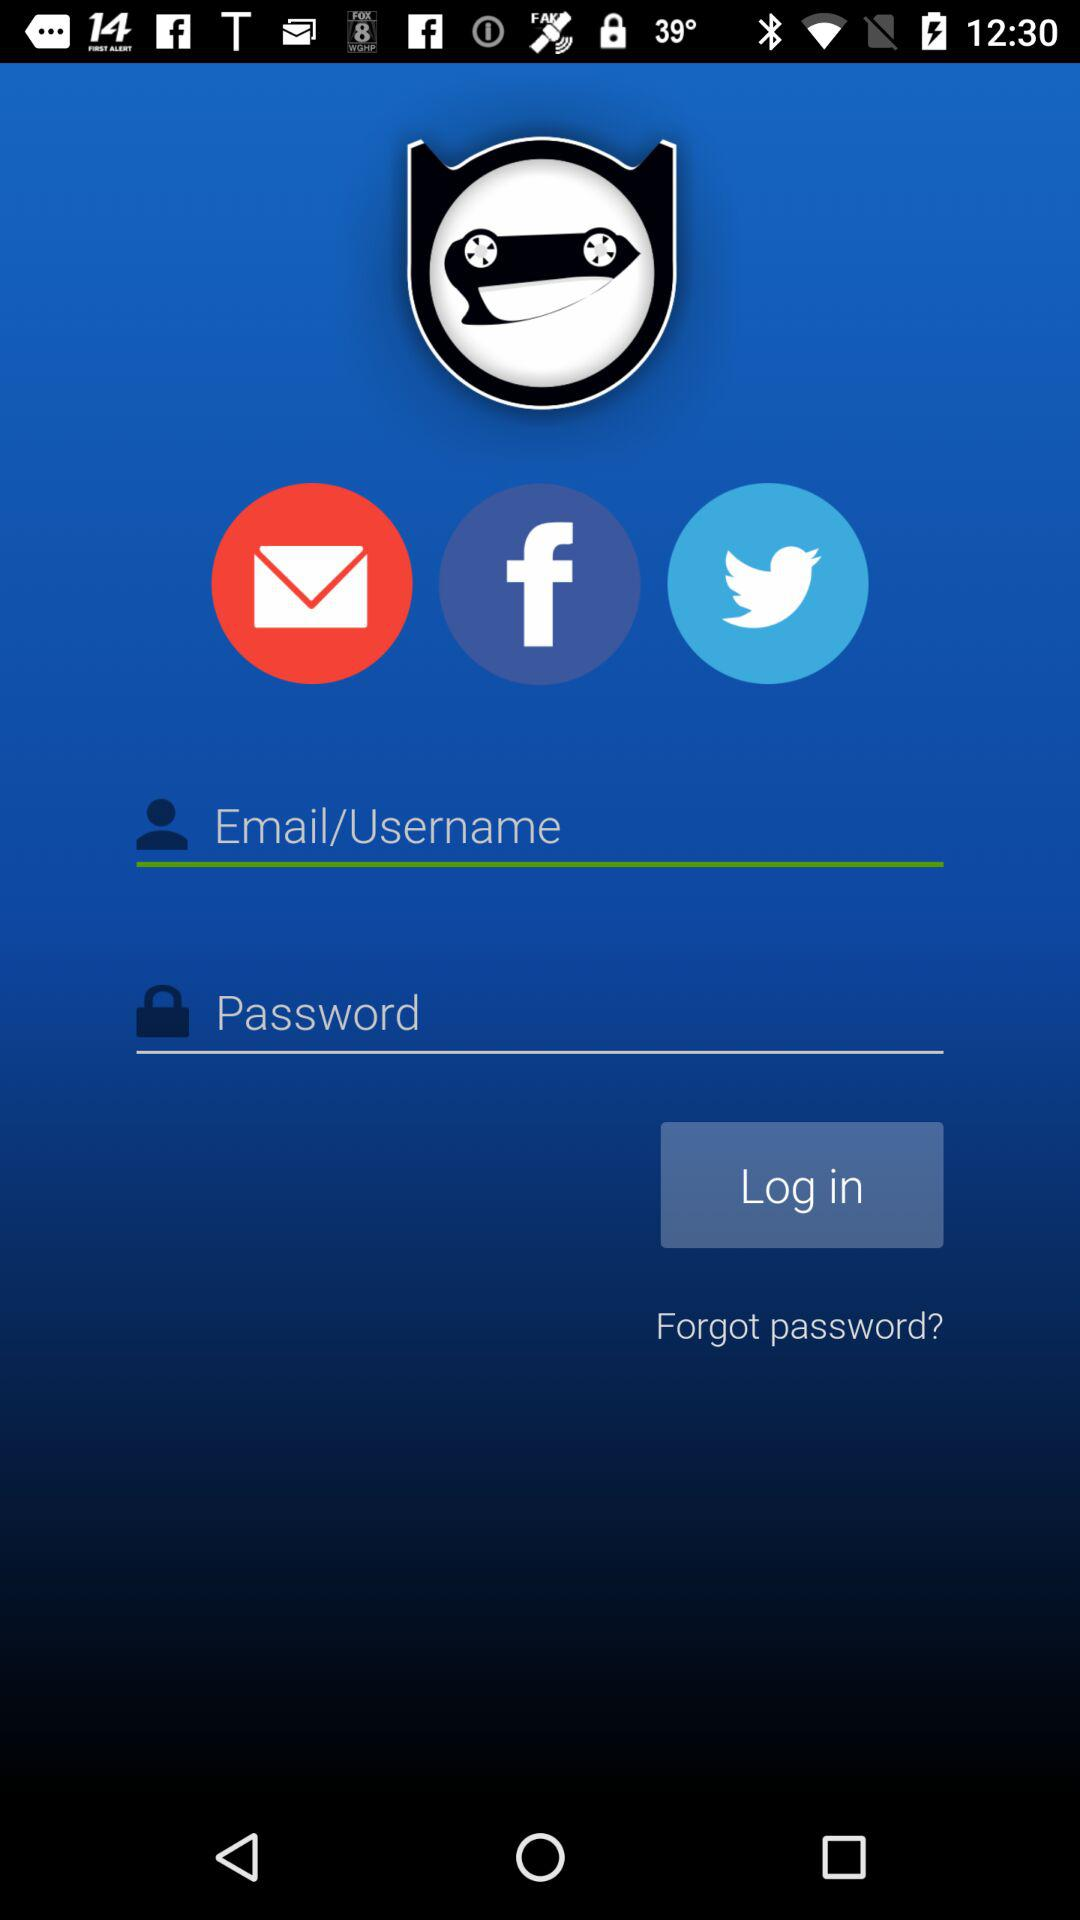Which applications can be used to log in? The applications "Facebook" and "Twitter" can be used to log in. 